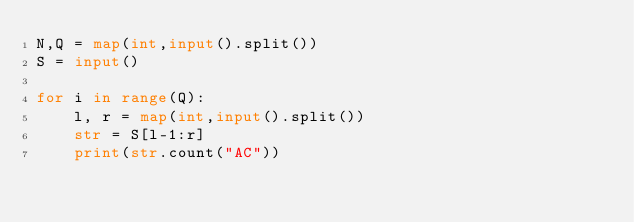<code> <loc_0><loc_0><loc_500><loc_500><_Python_>N,Q = map(int,input().split())
S = input()

for i in range(Q):
    l, r = map(int,input().split())
    str = S[l-1:r]
    print(str.count("AC"))</code> 